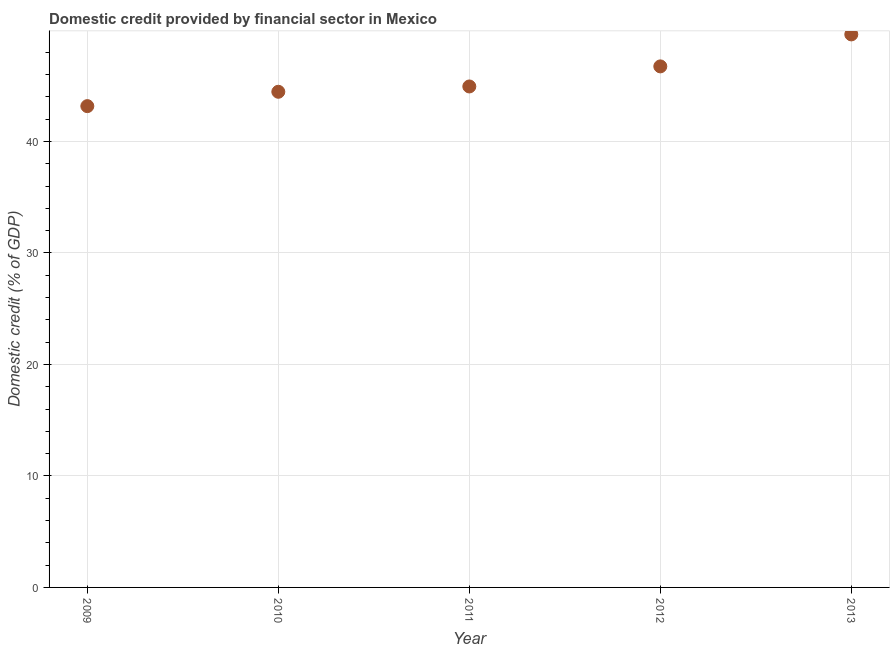What is the domestic credit provided by financial sector in 2009?
Ensure brevity in your answer.  43.17. Across all years, what is the maximum domestic credit provided by financial sector?
Provide a succinct answer. 49.6. Across all years, what is the minimum domestic credit provided by financial sector?
Make the answer very short. 43.17. What is the sum of the domestic credit provided by financial sector?
Ensure brevity in your answer.  228.91. What is the difference between the domestic credit provided by financial sector in 2011 and 2012?
Your answer should be very brief. -1.8. What is the average domestic credit provided by financial sector per year?
Your response must be concise. 45.78. What is the median domestic credit provided by financial sector?
Make the answer very short. 44.93. In how many years, is the domestic credit provided by financial sector greater than 42 %?
Provide a short and direct response. 5. What is the ratio of the domestic credit provided by financial sector in 2011 to that in 2013?
Your answer should be very brief. 0.91. Is the difference between the domestic credit provided by financial sector in 2009 and 2010 greater than the difference between any two years?
Offer a very short reply. No. What is the difference between the highest and the second highest domestic credit provided by financial sector?
Provide a short and direct response. 2.87. What is the difference between the highest and the lowest domestic credit provided by financial sector?
Give a very brief answer. 6.43. In how many years, is the domestic credit provided by financial sector greater than the average domestic credit provided by financial sector taken over all years?
Offer a very short reply. 2. Does the domestic credit provided by financial sector monotonically increase over the years?
Provide a succinct answer. Yes. How many dotlines are there?
Make the answer very short. 1. How many years are there in the graph?
Ensure brevity in your answer.  5. Are the values on the major ticks of Y-axis written in scientific E-notation?
Offer a terse response. No. Does the graph contain any zero values?
Ensure brevity in your answer.  No. What is the title of the graph?
Offer a terse response. Domestic credit provided by financial sector in Mexico. What is the label or title of the Y-axis?
Offer a very short reply. Domestic credit (% of GDP). What is the Domestic credit (% of GDP) in 2009?
Your answer should be compact. 43.17. What is the Domestic credit (% of GDP) in 2010?
Make the answer very short. 44.46. What is the Domestic credit (% of GDP) in 2011?
Your answer should be very brief. 44.93. What is the Domestic credit (% of GDP) in 2012?
Your answer should be very brief. 46.74. What is the Domestic credit (% of GDP) in 2013?
Your answer should be very brief. 49.6. What is the difference between the Domestic credit (% of GDP) in 2009 and 2010?
Ensure brevity in your answer.  -1.29. What is the difference between the Domestic credit (% of GDP) in 2009 and 2011?
Make the answer very short. -1.76. What is the difference between the Domestic credit (% of GDP) in 2009 and 2012?
Offer a very short reply. -3.56. What is the difference between the Domestic credit (% of GDP) in 2009 and 2013?
Offer a very short reply. -6.43. What is the difference between the Domestic credit (% of GDP) in 2010 and 2011?
Ensure brevity in your answer.  -0.48. What is the difference between the Domestic credit (% of GDP) in 2010 and 2012?
Make the answer very short. -2.28. What is the difference between the Domestic credit (% of GDP) in 2010 and 2013?
Give a very brief answer. -5.14. What is the difference between the Domestic credit (% of GDP) in 2011 and 2012?
Make the answer very short. -1.8. What is the difference between the Domestic credit (% of GDP) in 2011 and 2013?
Provide a succinct answer. -4.67. What is the difference between the Domestic credit (% of GDP) in 2012 and 2013?
Your response must be concise. -2.87. What is the ratio of the Domestic credit (% of GDP) in 2009 to that in 2011?
Your answer should be very brief. 0.96. What is the ratio of the Domestic credit (% of GDP) in 2009 to that in 2012?
Your answer should be very brief. 0.92. What is the ratio of the Domestic credit (% of GDP) in 2009 to that in 2013?
Make the answer very short. 0.87. What is the ratio of the Domestic credit (% of GDP) in 2010 to that in 2011?
Provide a short and direct response. 0.99. What is the ratio of the Domestic credit (% of GDP) in 2010 to that in 2012?
Your answer should be very brief. 0.95. What is the ratio of the Domestic credit (% of GDP) in 2010 to that in 2013?
Make the answer very short. 0.9. What is the ratio of the Domestic credit (% of GDP) in 2011 to that in 2012?
Offer a terse response. 0.96. What is the ratio of the Domestic credit (% of GDP) in 2011 to that in 2013?
Give a very brief answer. 0.91. What is the ratio of the Domestic credit (% of GDP) in 2012 to that in 2013?
Offer a very short reply. 0.94. 